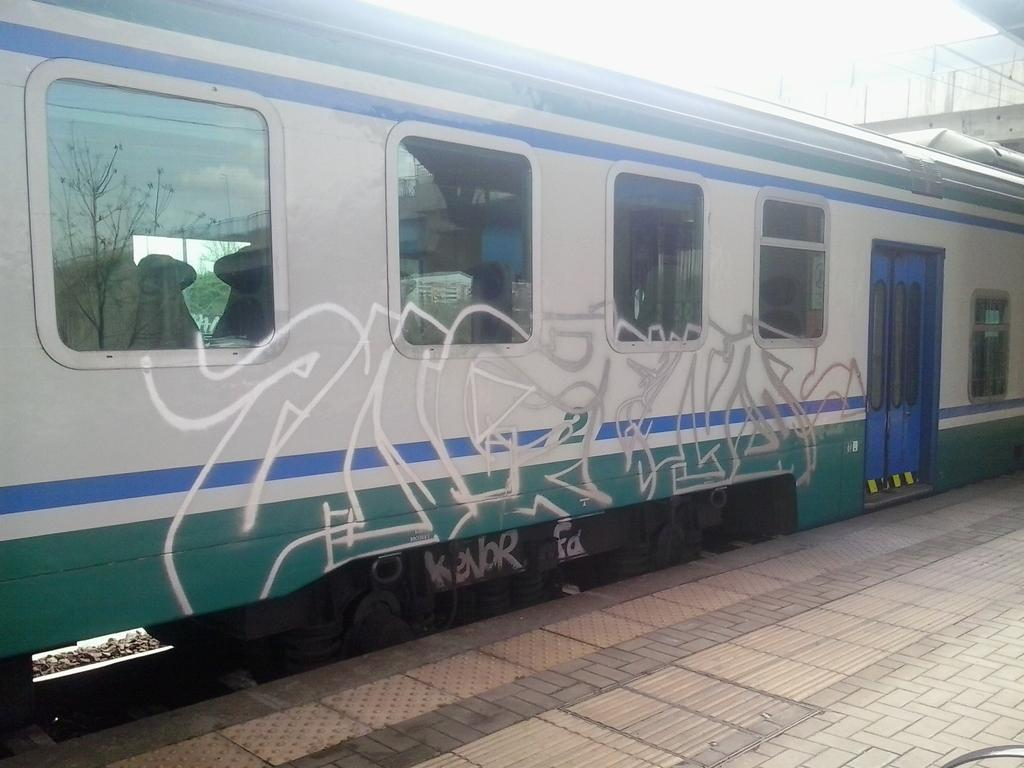What is the main subject of the image? The main subject of the image is a train. What features can be seen on the train? The train has doors and windows. What is located at the bottom of the image? There is a platform at the bottom of the image. What can be seen in the top right corner of the image? There is a bridge in the top right corner of the image. What is the price of the coast visible in the image? There is no coast present in the image, and therefore no price can be determined. How many legs does the train have in the image? Trains do not have legs; they are vehicles that run on tracks. 